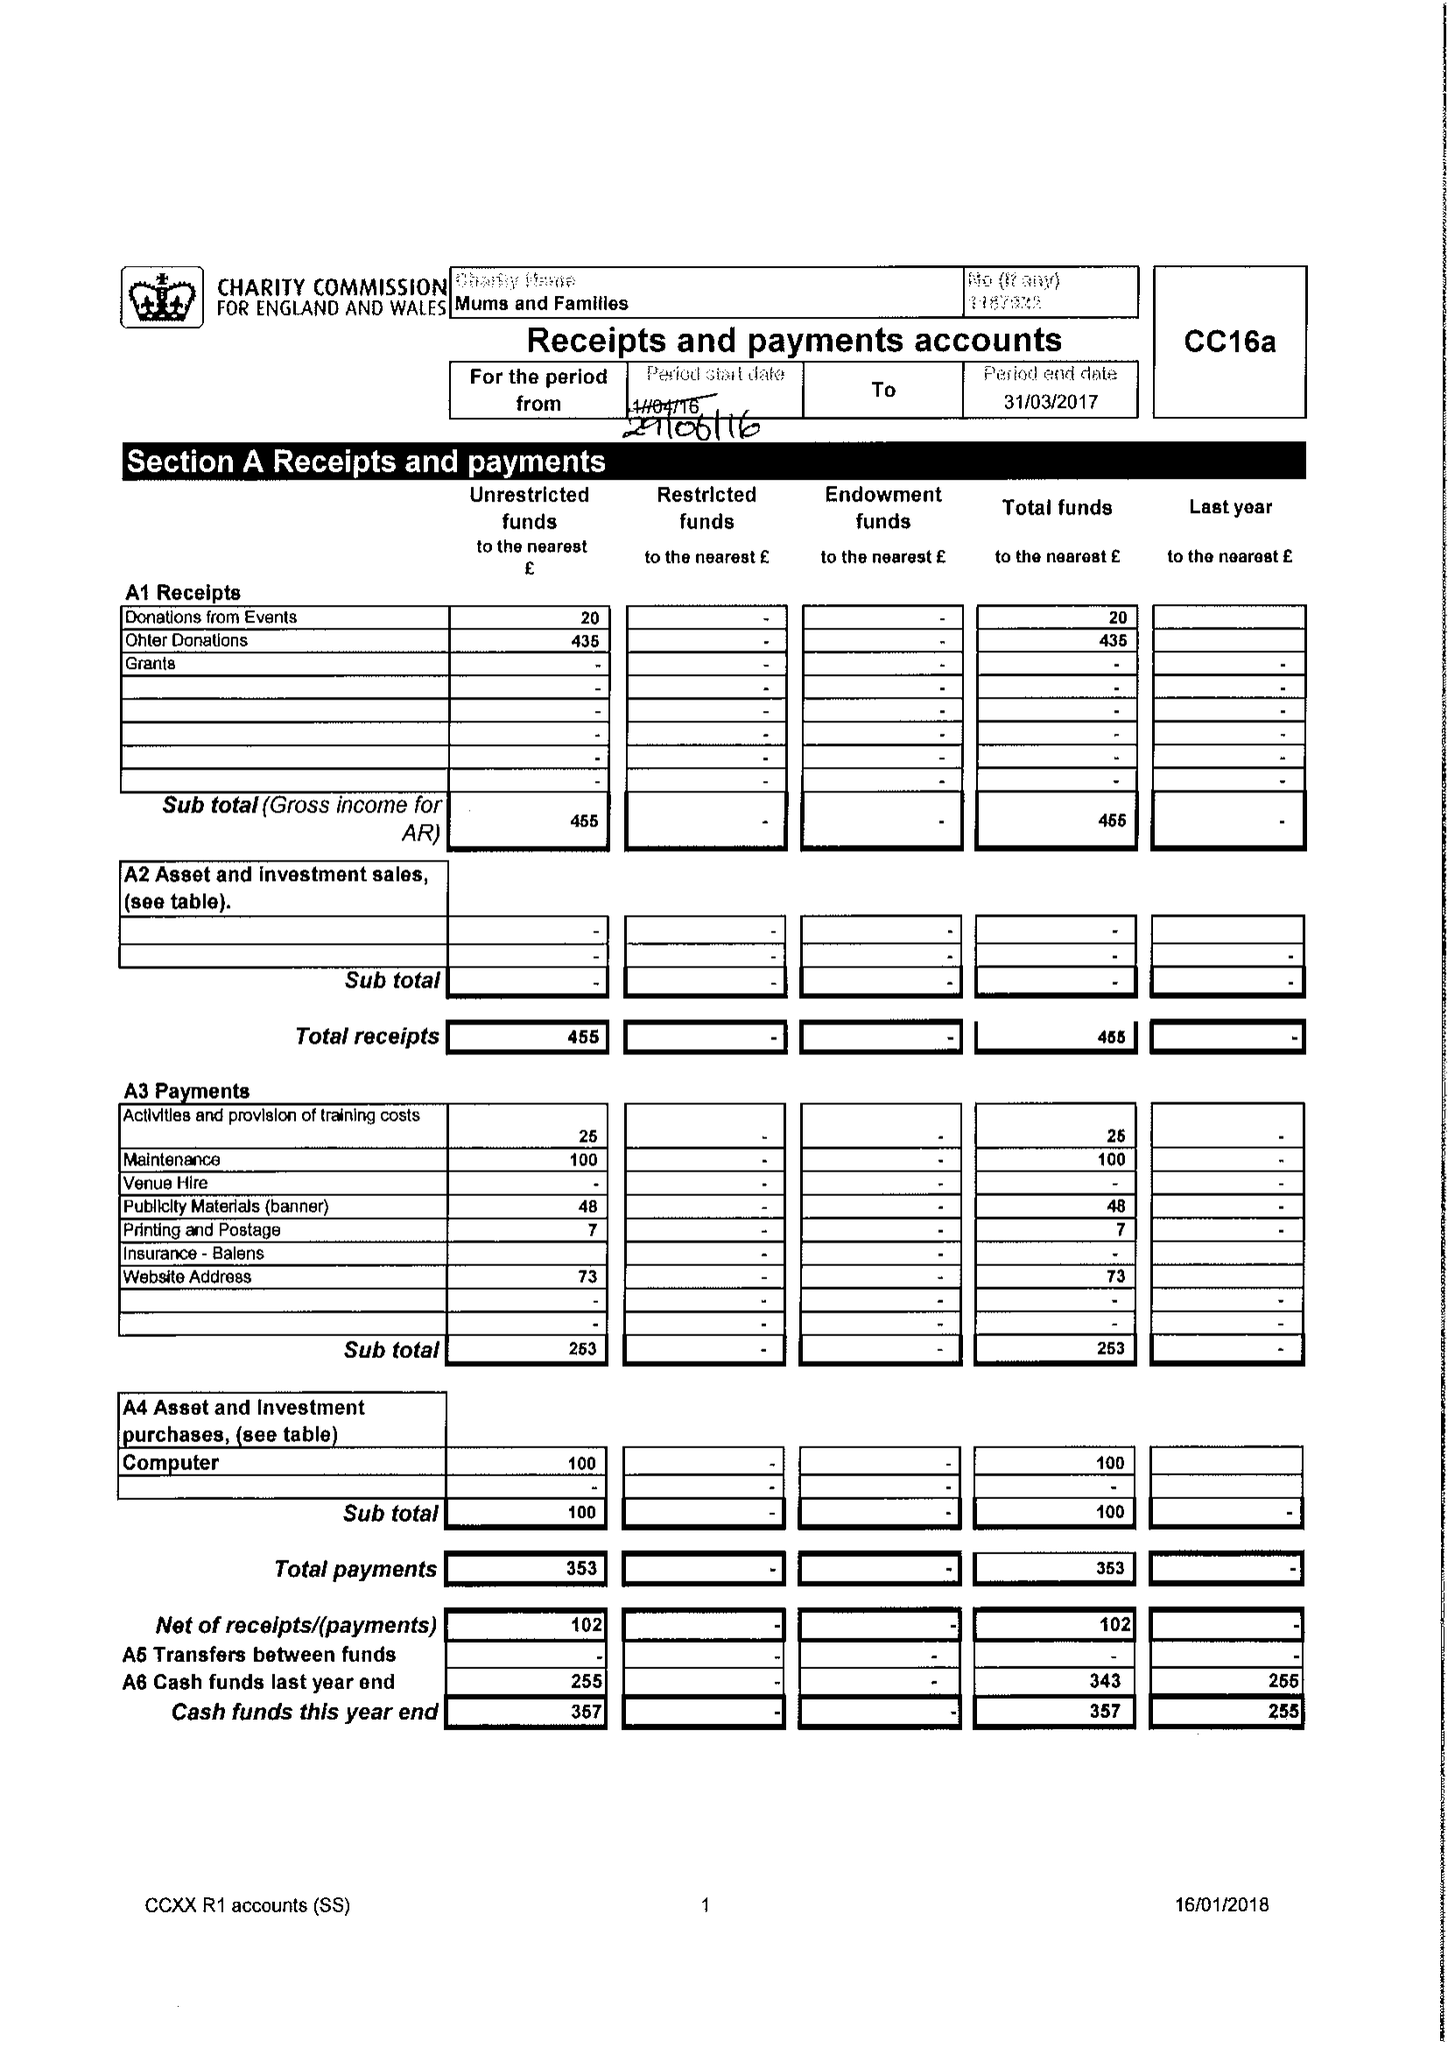What is the value for the report_date?
Answer the question using a single word or phrase. 2017-03-31 